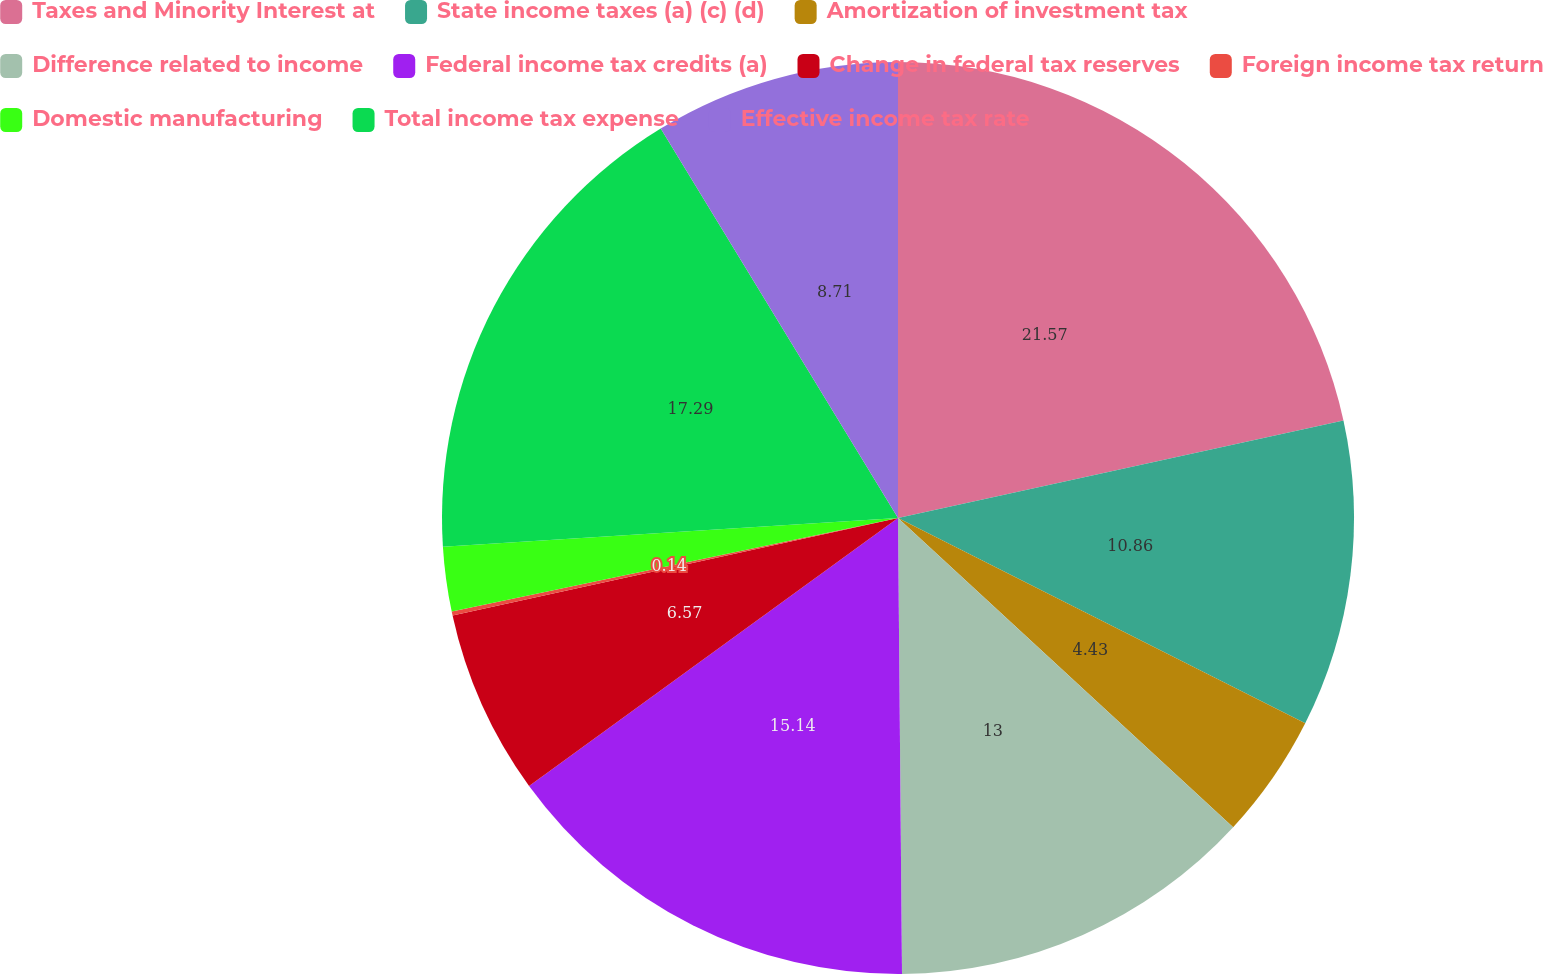Convert chart. <chart><loc_0><loc_0><loc_500><loc_500><pie_chart><fcel>Taxes and Minority Interest at<fcel>State income taxes (a) (c) (d)<fcel>Amortization of investment tax<fcel>Difference related to income<fcel>Federal income tax credits (a)<fcel>Change in federal tax reserves<fcel>Foreign income tax return<fcel>Domestic manufacturing<fcel>Total income tax expense<fcel>Effective income tax rate<nl><fcel>21.57%<fcel>10.86%<fcel>4.43%<fcel>13.0%<fcel>15.14%<fcel>6.57%<fcel>0.14%<fcel>2.29%<fcel>17.29%<fcel>8.71%<nl></chart> 